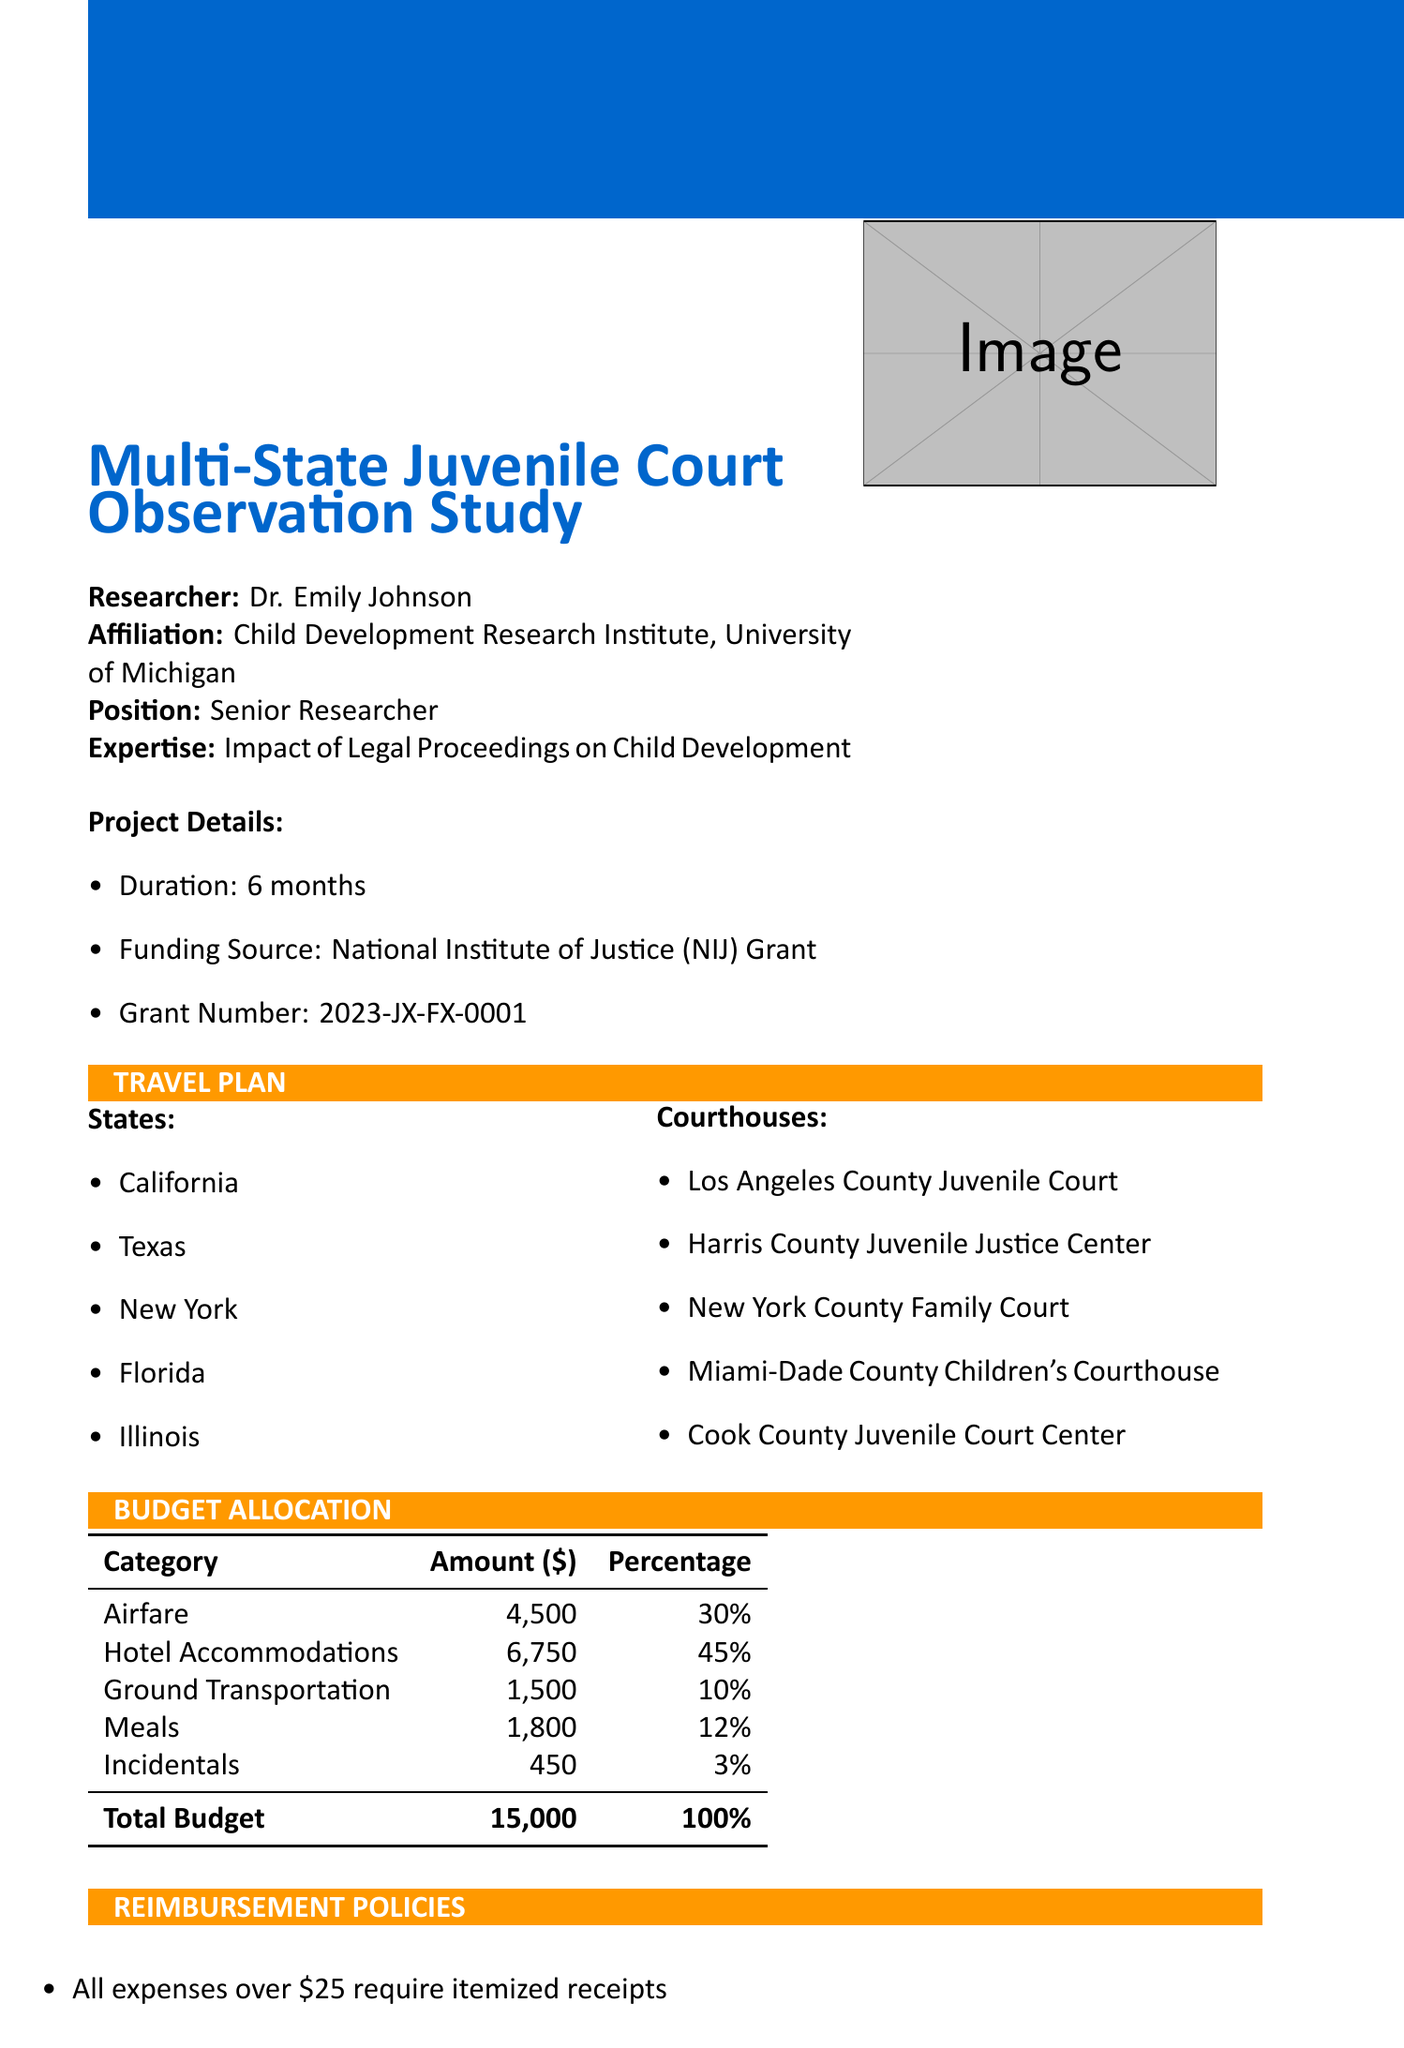What is the total budget? The total budget is explicitly stated in the budget allocation section of the document.
Answer: 15000 Who is the lead researcher? The document clearly identifies Dr. Emily Johnson as the researcher in the initial section.
Answer: Dr. Emily Johnson What is the lodging limit per night? The lodging limit is specified within the reimbursement policies, providing a clear figure for accommodation costs.
Answer: 150 How many states are included in the travel plan? The number of states listed under the travel plan section can be counted directly in the document.
Answer: 5 What is the per diem rate for meals? The per diem rate for meals is mentioned explicitly in the reimbursement policies, providing a clear amount for meal expenses.
Answer: 60 Why is there a need for confidentiality in court observations? The ethical considerations section addresses confidentiality requirements to adhere to local juvenile privacy laws.
Answer: Local juvenile privacy laws What is the deadline for submitting reimbursement claims? The deadline for submission is clearly stated within the submission process section of the document.
Answer: Within 30 days What form is to be used for reimbursement submission? The document specifies the required form for reimbursement in the submission process section.
Answer: NIJ Travel Expense Reimbursement Form (SF-1012) What percentage of the budget is allocated for hotel accommodations? The budget allocation section includes precise percentages for each category, allowing for this calculation.
Answer: 45% 